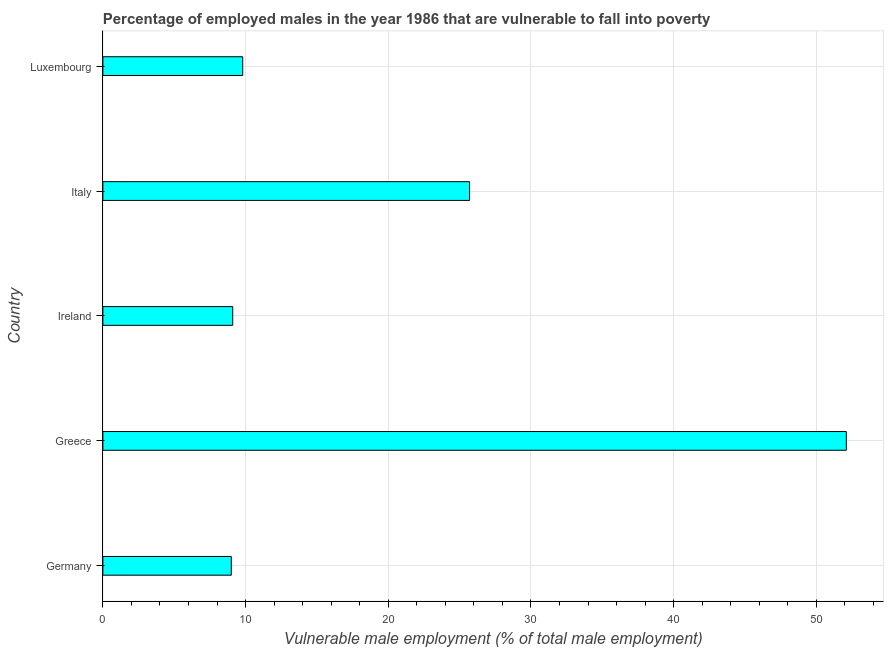Does the graph contain any zero values?
Offer a terse response. No. Does the graph contain grids?
Give a very brief answer. Yes. What is the title of the graph?
Provide a succinct answer. Percentage of employed males in the year 1986 that are vulnerable to fall into poverty. What is the label or title of the X-axis?
Keep it short and to the point. Vulnerable male employment (% of total male employment). What is the label or title of the Y-axis?
Your response must be concise. Country. What is the percentage of employed males who are vulnerable to fall into poverty in Luxembourg?
Your answer should be very brief. 9.8. Across all countries, what is the maximum percentage of employed males who are vulnerable to fall into poverty?
Provide a short and direct response. 52.1. In which country was the percentage of employed males who are vulnerable to fall into poverty maximum?
Keep it short and to the point. Greece. In which country was the percentage of employed males who are vulnerable to fall into poverty minimum?
Your answer should be very brief. Germany. What is the sum of the percentage of employed males who are vulnerable to fall into poverty?
Give a very brief answer. 105.7. What is the difference between the percentage of employed males who are vulnerable to fall into poverty in Ireland and Luxembourg?
Provide a short and direct response. -0.7. What is the average percentage of employed males who are vulnerable to fall into poverty per country?
Offer a terse response. 21.14. What is the median percentage of employed males who are vulnerable to fall into poverty?
Your response must be concise. 9.8. In how many countries, is the percentage of employed males who are vulnerable to fall into poverty greater than 46 %?
Your response must be concise. 1. What is the ratio of the percentage of employed males who are vulnerable to fall into poverty in Ireland to that in Luxembourg?
Offer a very short reply. 0.93. What is the difference between the highest and the second highest percentage of employed males who are vulnerable to fall into poverty?
Your answer should be very brief. 26.4. Is the sum of the percentage of employed males who are vulnerable to fall into poverty in Germany and Luxembourg greater than the maximum percentage of employed males who are vulnerable to fall into poverty across all countries?
Provide a succinct answer. No. What is the difference between the highest and the lowest percentage of employed males who are vulnerable to fall into poverty?
Keep it short and to the point. 43.1. In how many countries, is the percentage of employed males who are vulnerable to fall into poverty greater than the average percentage of employed males who are vulnerable to fall into poverty taken over all countries?
Your answer should be very brief. 2. Are all the bars in the graph horizontal?
Provide a succinct answer. Yes. Are the values on the major ticks of X-axis written in scientific E-notation?
Give a very brief answer. No. What is the Vulnerable male employment (% of total male employment) in Germany?
Provide a short and direct response. 9. What is the Vulnerable male employment (% of total male employment) of Greece?
Make the answer very short. 52.1. What is the Vulnerable male employment (% of total male employment) of Ireland?
Keep it short and to the point. 9.1. What is the Vulnerable male employment (% of total male employment) in Italy?
Make the answer very short. 25.7. What is the Vulnerable male employment (% of total male employment) of Luxembourg?
Your response must be concise. 9.8. What is the difference between the Vulnerable male employment (% of total male employment) in Germany and Greece?
Offer a very short reply. -43.1. What is the difference between the Vulnerable male employment (% of total male employment) in Germany and Ireland?
Provide a succinct answer. -0.1. What is the difference between the Vulnerable male employment (% of total male employment) in Germany and Italy?
Keep it short and to the point. -16.7. What is the difference between the Vulnerable male employment (% of total male employment) in Germany and Luxembourg?
Ensure brevity in your answer.  -0.8. What is the difference between the Vulnerable male employment (% of total male employment) in Greece and Italy?
Offer a terse response. 26.4. What is the difference between the Vulnerable male employment (% of total male employment) in Greece and Luxembourg?
Offer a very short reply. 42.3. What is the difference between the Vulnerable male employment (% of total male employment) in Ireland and Italy?
Give a very brief answer. -16.6. What is the difference between the Vulnerable male employment (% of total male employment) in Italy and Luxembourg?
Your answer should be very brief. 15.9. What is the ratio of the Vulnerable male employment (% of total male employment) in Germany to that in Greece?
Give a very brief answer. 0.17. What is the ratio of the Vulnerable male employment (% of total male employment) in Germany to that in Italy?
Ensure brevity in your answer.  0.35. What is the ratio of the Vulnerable male employment (% of total male employment) in Germany to that in Luxembourg?
Ensure brevity in your answer.  0.92. What is the ratio of the Vulnerable male employment (% of total male employment) in Greece to that in Ireland?
Make the answer very short. 5.72. What is the ratio of the Vulnerable male employment (% of total male employment) in Greece to that in Italy?
Provide a succinct answer. 2.03. What is the ratio of the Vulnerable male employment (% of total male employment) in Greece to that in Luxembourg?
Your answer should be compact. 5.32. What is the ratio of the Vulnerable male employment (% of total male employment) in Ireland to that in Italy?
Provide a short and direct response. 0.35. What is the ratio of the Vulnerable male employment (% of total male employment) in Ireland to that in Luxembourg?
Your answer should be compact. 0.93. What is the ratio of the Vulnerable male employment (% of total male employment) in Italy to that in Luxembourg?
Provide a short and direct response. 2.62. 